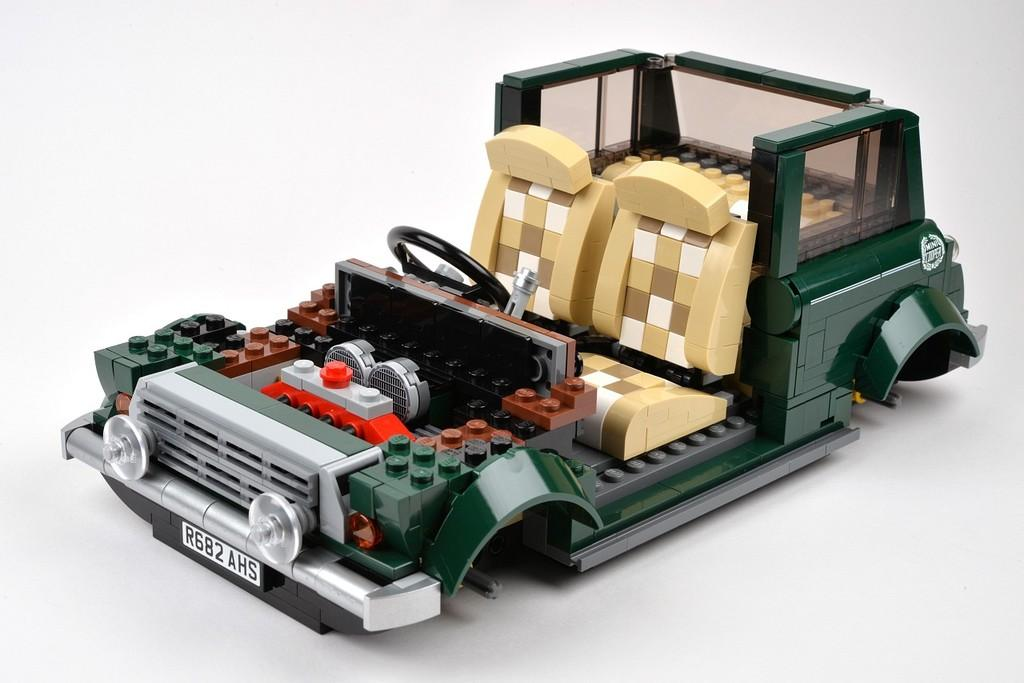What object can be seen in the image? There is a toy in the image. What color is the background of the image? The background of the image is white. What is located in the foreground of the image? There is text in the foreground of the image. What type of object has numbers on it in the image? There are numbers on a vehicle in the image. What is the price of the zinc in the image? There is no zinc or price information present in the image. 